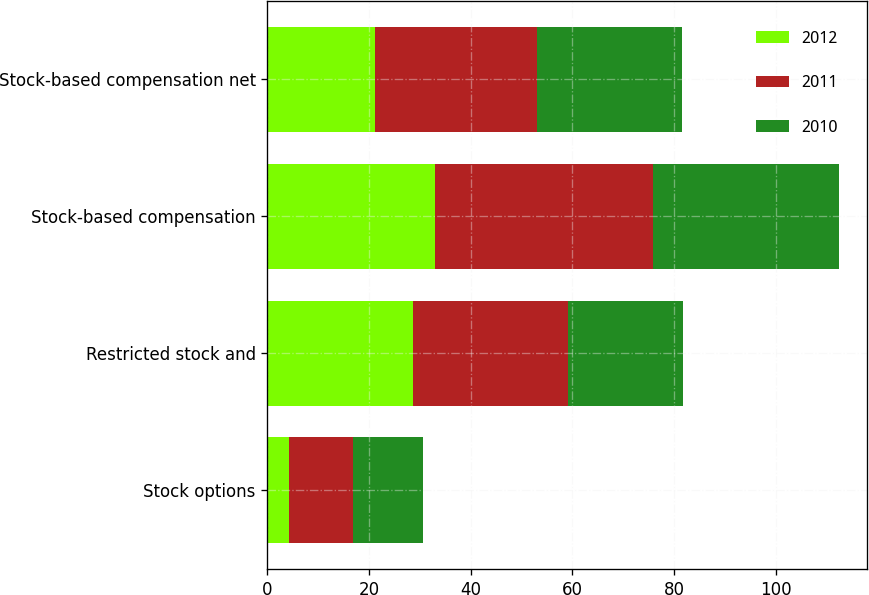Convert chart to OTSL. <chart><loc_0><loc_0><loc_500><loc_500><stacked_bar_chart><ecel><fcel>Stock options<fcel>Restricted stock and<fcel>Stock-based compensation<fcel>Stock-based compensation net<nl><fcel>2012<fcel>4.3<fcel>28.6<fcel>32.9<fcel>21.2<nl><fcel>2011<fcel>12.5<fcel>30.5<fcel>43<fcel>31.8<nl><fcel>2010<fcel>13.9<fcel>22.6<fcel>36.5<fcel>28.5<nl></chart> 